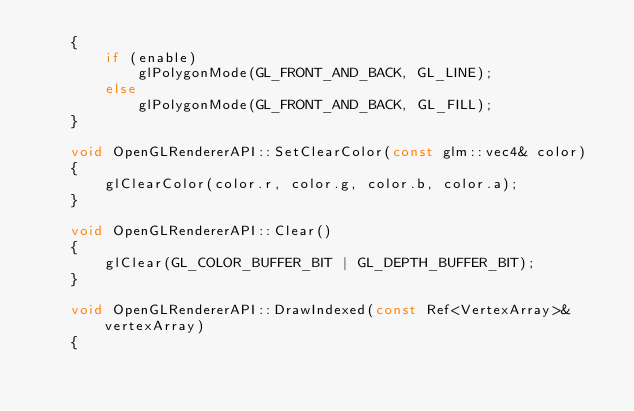<code> <loc_0><loc_0><loc_500><loc_500><_C++_>	{
		if (enable)
			glPolygonMode(GL_FRONT_AND_BACK, GL_LINE);
		else
			glPolygonMode(GL_FRONT_AND_BACK, GL_FILL);
	}

	void OpenGLRendererAPI::SetClearColor(const glm::vec4& color)
	{
		glClearColor(color.r, color.g, color.b, color.a);
	}

	void OpenGLRendererAPI::Clear()
	{
		glClear(GL_COLOR_BUFFER_BIT | GL_DEPTH_BUFFER_BIT);
	}

	void OpenGLRendererAPI::DrawIndexed(const Ref<VertexArray>& vertexArray)
	{</code> 